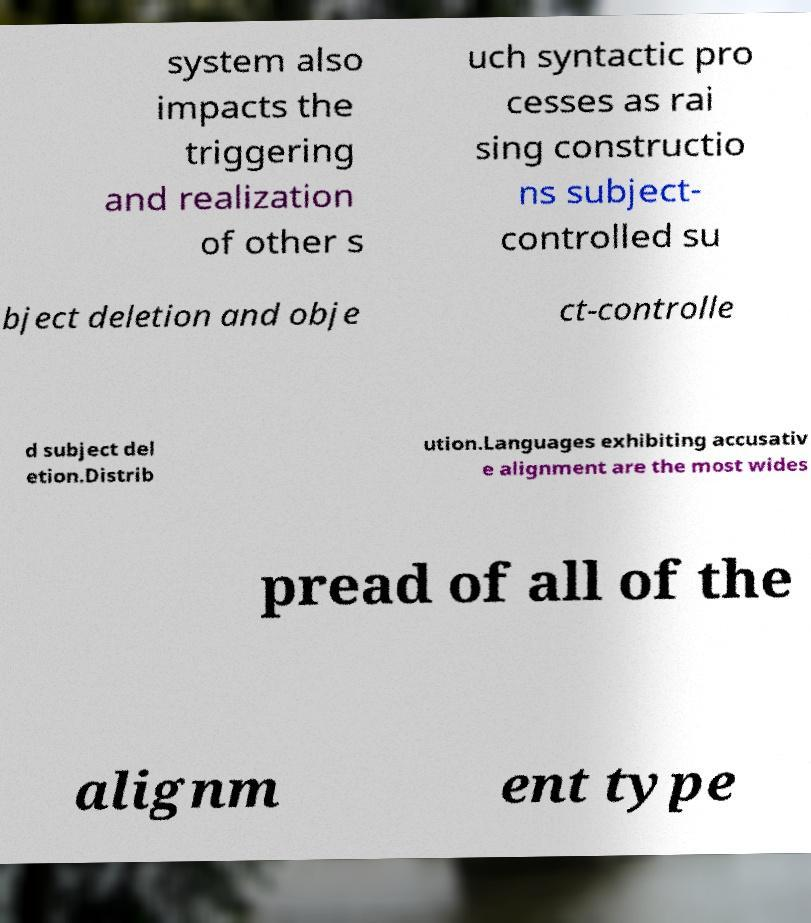Can you read and provide the text displayed in the image?This photo seems to have some interesting text. Can you extract and type it out for me? system also impacts the triggering and realization of other s uch syntactic pro cesses as rai sing constructio ns subject- controlled su bject deletion and obje ct-controlle d subject del etion.Distrib ution.Languages exhibiting accusativ e alignment are the most wides pread of all of the alignm ent type 